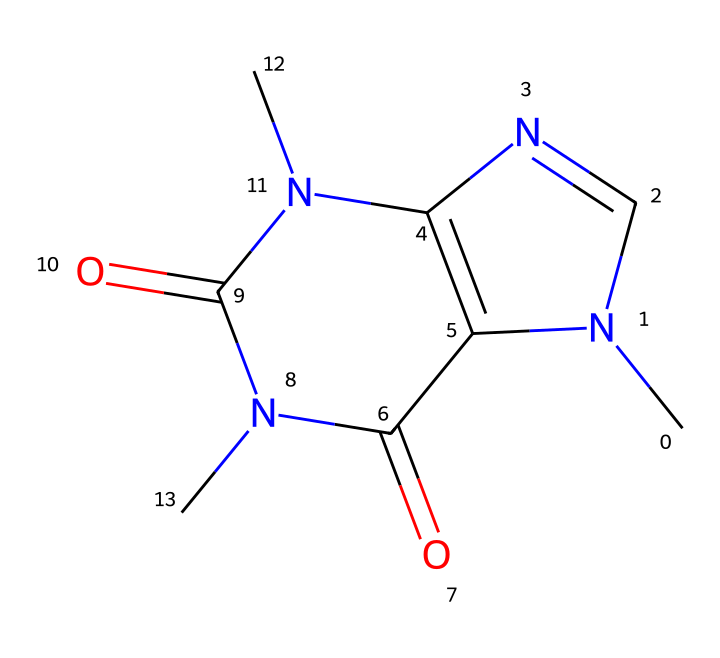What is the chemical name of the compound represented by this SMILES? The SMILES structure corresponds to caffeine, which is a well-known stimulant commonly found in tea and coffee.
Answer: caffeine How many nitrogen atoms are present in this chemical structure? By inspecting the SMILES, we identify the nitrogen atoms ('N') within the structure. There are 4 nitrogen atoms present in the caffeine's structure.
Answer: 4 What type of rings are present in the structure of caffeine? The structure contains two fused rings; the presence of 'C' and 'N' along with the cyclic format indicates a bicyclic structure, which includes both a pyrimidine and an imidazole ring in caffeine.
Answer: bicyclic What is the molecular formula of caffeine based on its structure? By counting the atoms in the given SMILES notation, we find that caffeine has a molecular formula of C8H10N4O2. This takes into account the carbons, hydrogens, nitrogens, and oxygens counted from the structure.
Answer: C8H10N4O2 Does caffeine have any functional groups? The presence of carbonyl groups (=O) and the nitrogen atoms (N) in the structure indicates that caffeine contains amide functional groups. This can be inferred from the arrangement of carbons and nitrogens in the molecule.
Answer: amide What type of classification does caffeine belong to in terms of chemical compounds? Caffeine is classified as an alkaloid, which is a group of naturally occurring organic compounds that mostly contain basic nitrogen atoms. The presence of several nitrogen atoms in the structure indicates this classification.
Answer: alkaloid How many rings are present in the caffeine structure? The caffeine structure clearly exhibits two interconnected rings, which can be confirmed by the cyclic part of the SMILES notation along with the arrangement of atoms that forms the ring structure.
Answer: 2 